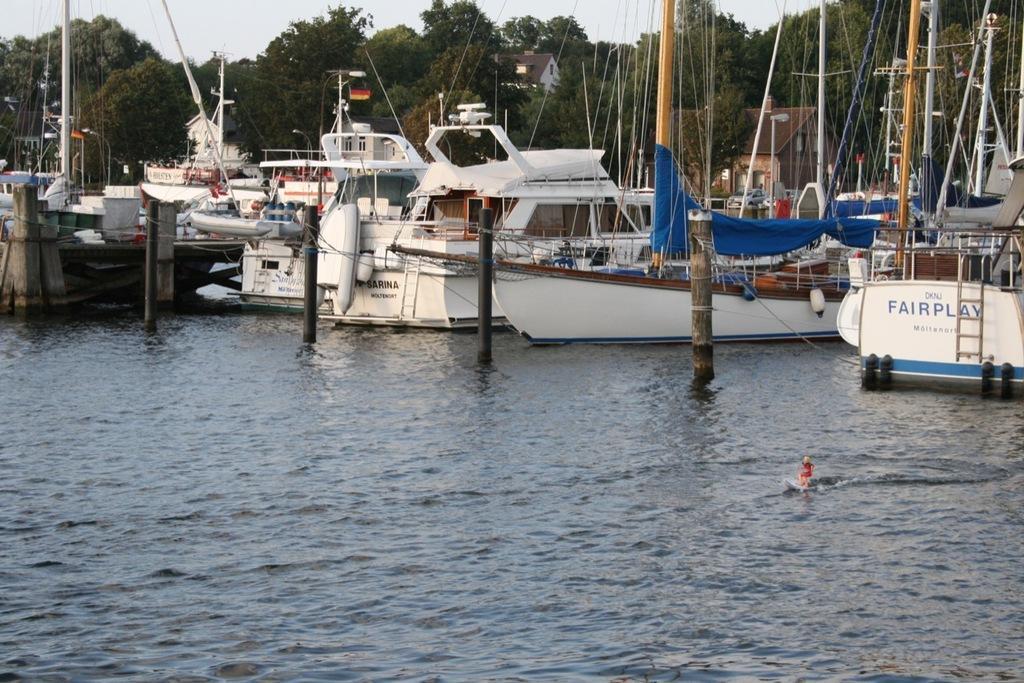Can you describe this image briefly? In this image there are ships on the water. On the ships there are banners, poles, threads, ropes, and there are trees in the background, there are buildings. In the front there is a water. 